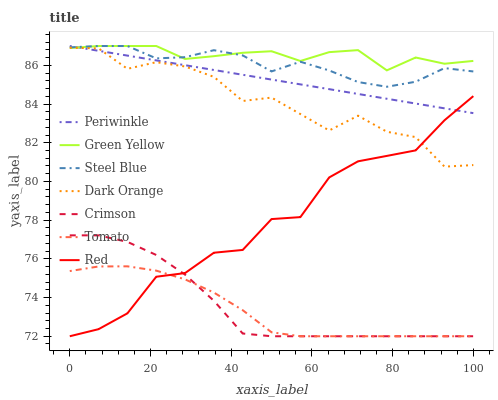Does Dark Orange have the minimum area under the curve?
Answer yes or no. No. Does Dark Orange have the maximum area under the curve?
Answer yes or no. No. Is Dark Orange the smoothest?
Answer yes or no. No. Is Dark Orange the roughest?
Answer yes or no. No. Does Dark Orange have the lowest value?
Answer yes or no. No. Does Dark Orange have the highest value?
Answer yes or no. No. Is Crimson less than Green Yellow?
Answer yes or no. Yes. Is Periwinkle greater than Crimson?
Answer yes or no. Yes. Does Crimson intersect Green Yellow?
Answer yes or no. No. 